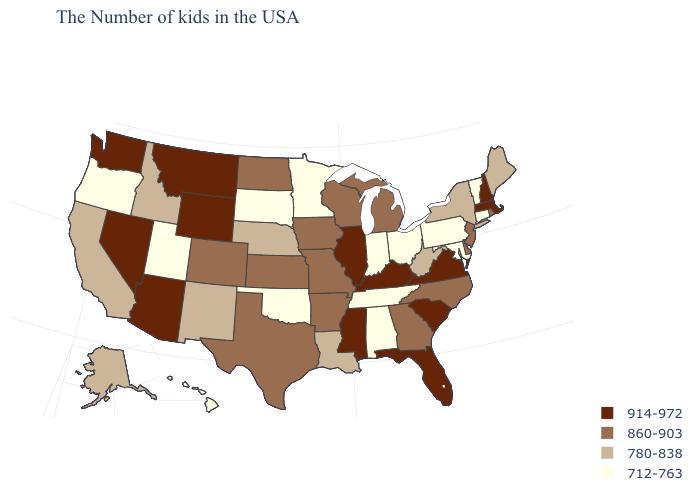Does Maryland have the highest value in the USA?
Keep it brief. No. Name the states that have a value in the range 860-903?
Concise answer only. Rhode Island, New Jersey, Delaware, North Carolina, Georgia, Michigan, Wisconsin, Missouri, Arkansas, Iowa, Kansas, Texas, North Dakota, Colorado. What is the lowest value in the USA?
Concise answer only. 712-763. What is the lowest value in states that border Connecticut?
Write a very short answer. 780-838. Which states have the lowest value in the South?
Quick response, please. Maryland, Alabama, Tennessee, Oklahoma. Name the states that have a value in the range 780-838?
Quick response, please. Maine, New York, West Virginia, Louisiana, Nebraska, New Mexico, Idaho, California, Alaska. What is the value of Tennessee?
Short answer required. 712-763. Name the states that have a value in the range 712-763?
Answer briefly. Vermont, Connecticut, Maryland, Pennsylvania, Ohio, Indiana, Alabama, Tennessee, Minnesota, Oklahoma, South Dakota, Utah, Oregon, Hawaii. Does Iowa have the lowest value in the MidWest?
Keep it brief. No. Name the states that have a value in the range 860-903?
Concise answer only. Rhode Island, New Jersey, Delaware, North Carolina, Georgia, Michigan, Wisconsin, Missouri, Arkansas, Iowa, Kansas, Texas, North Dakota, Colorado. What is the value of Delaware?
Quick response, please. 860-903. What is the value of Oklahoma?
Give a very brief answer. 712-763. Name the states that have a value in the range 860-903?
Write a very short answer. Rhode Island, New Jersey, Delaware, North Carolina, Georgia, Michigan, Wisconsin, Missouri, Arkansas, Iowa, Kansas, Texas, North Dakota, Colorado. Among the states that border Florida , does Georgia have the highest value?
Quick response, please. Yes. What is the lowest value in states that border Delaware?
Keep it brief. 712-763. 